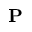<formula> <loc_0><loc_0><loc_500><loc_500>P</formula> 